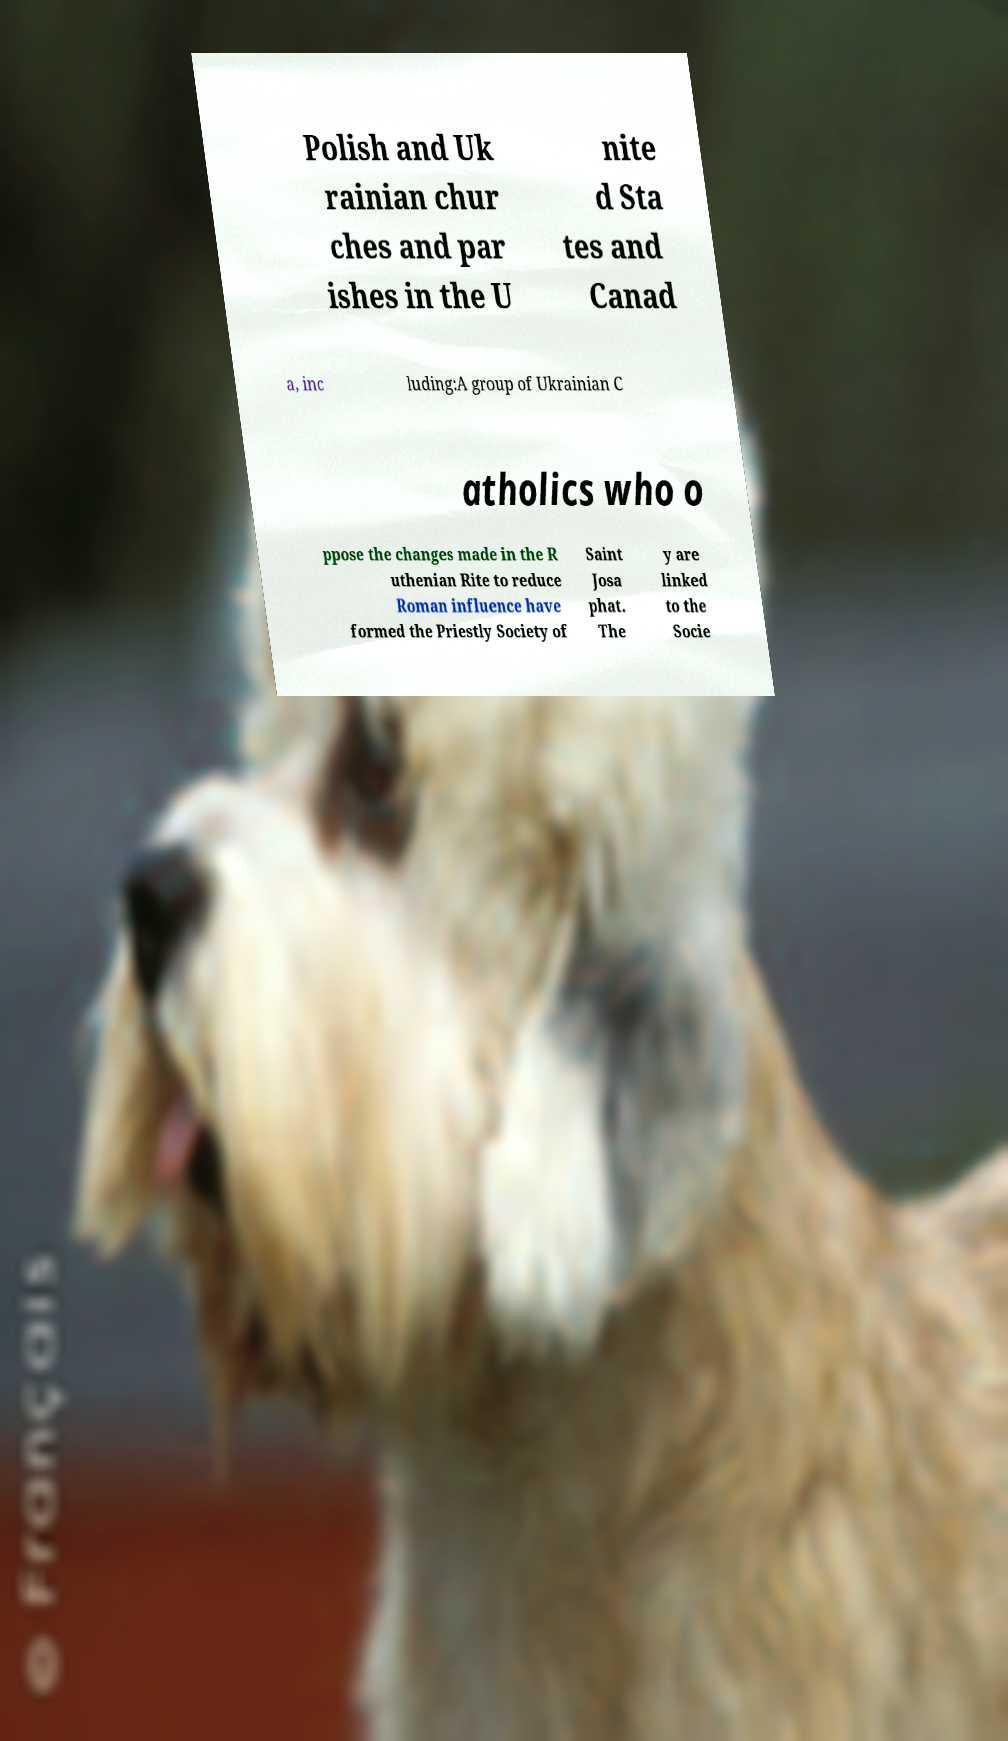Please identify and transcribe the text found in this image. Polish and Uk rainian chur ches and par ishes in the U nite d Sta tes and Canad a, inc luding:A group of Ukrainian C atholics who o ppose the changes made in the R uthenian Rite to reduce Roman influence have formed the Priestly Society of Saint Josa phat. The y are linked to the Socie 